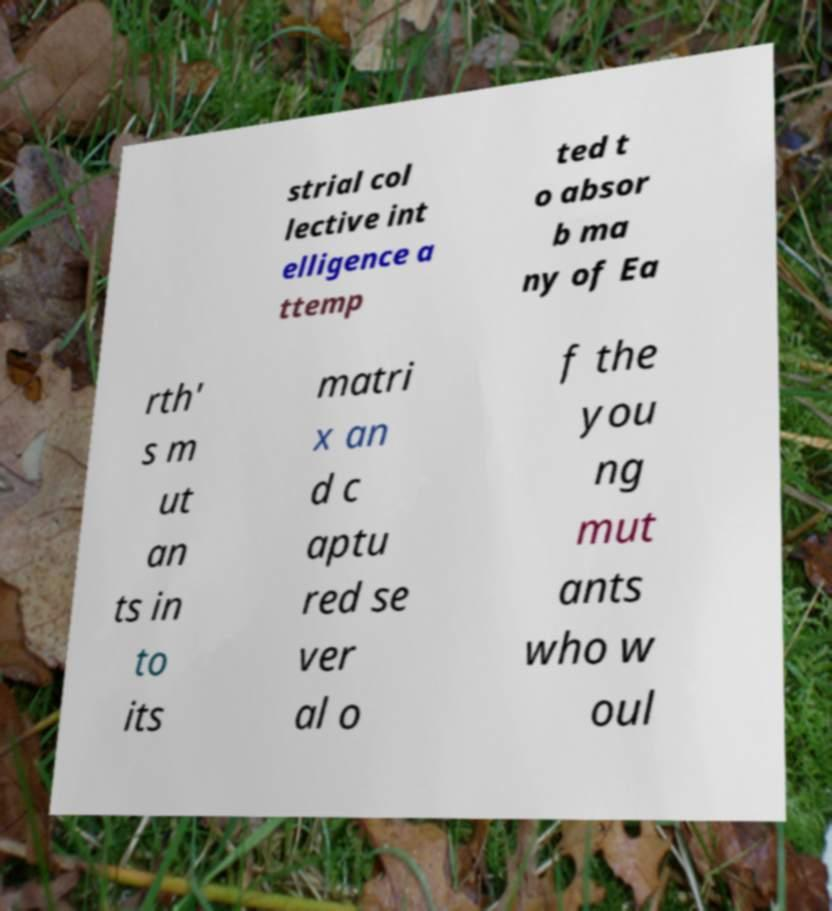What messages or text are displayed in this image? I need them in a readable, typed format. strial col lective int elligence a ttemp ted t o absor b ma ny of Ea rth' s m ut an ts in to its matri x an d c aptu red se ver al o f the you ng mut ants who w oul 